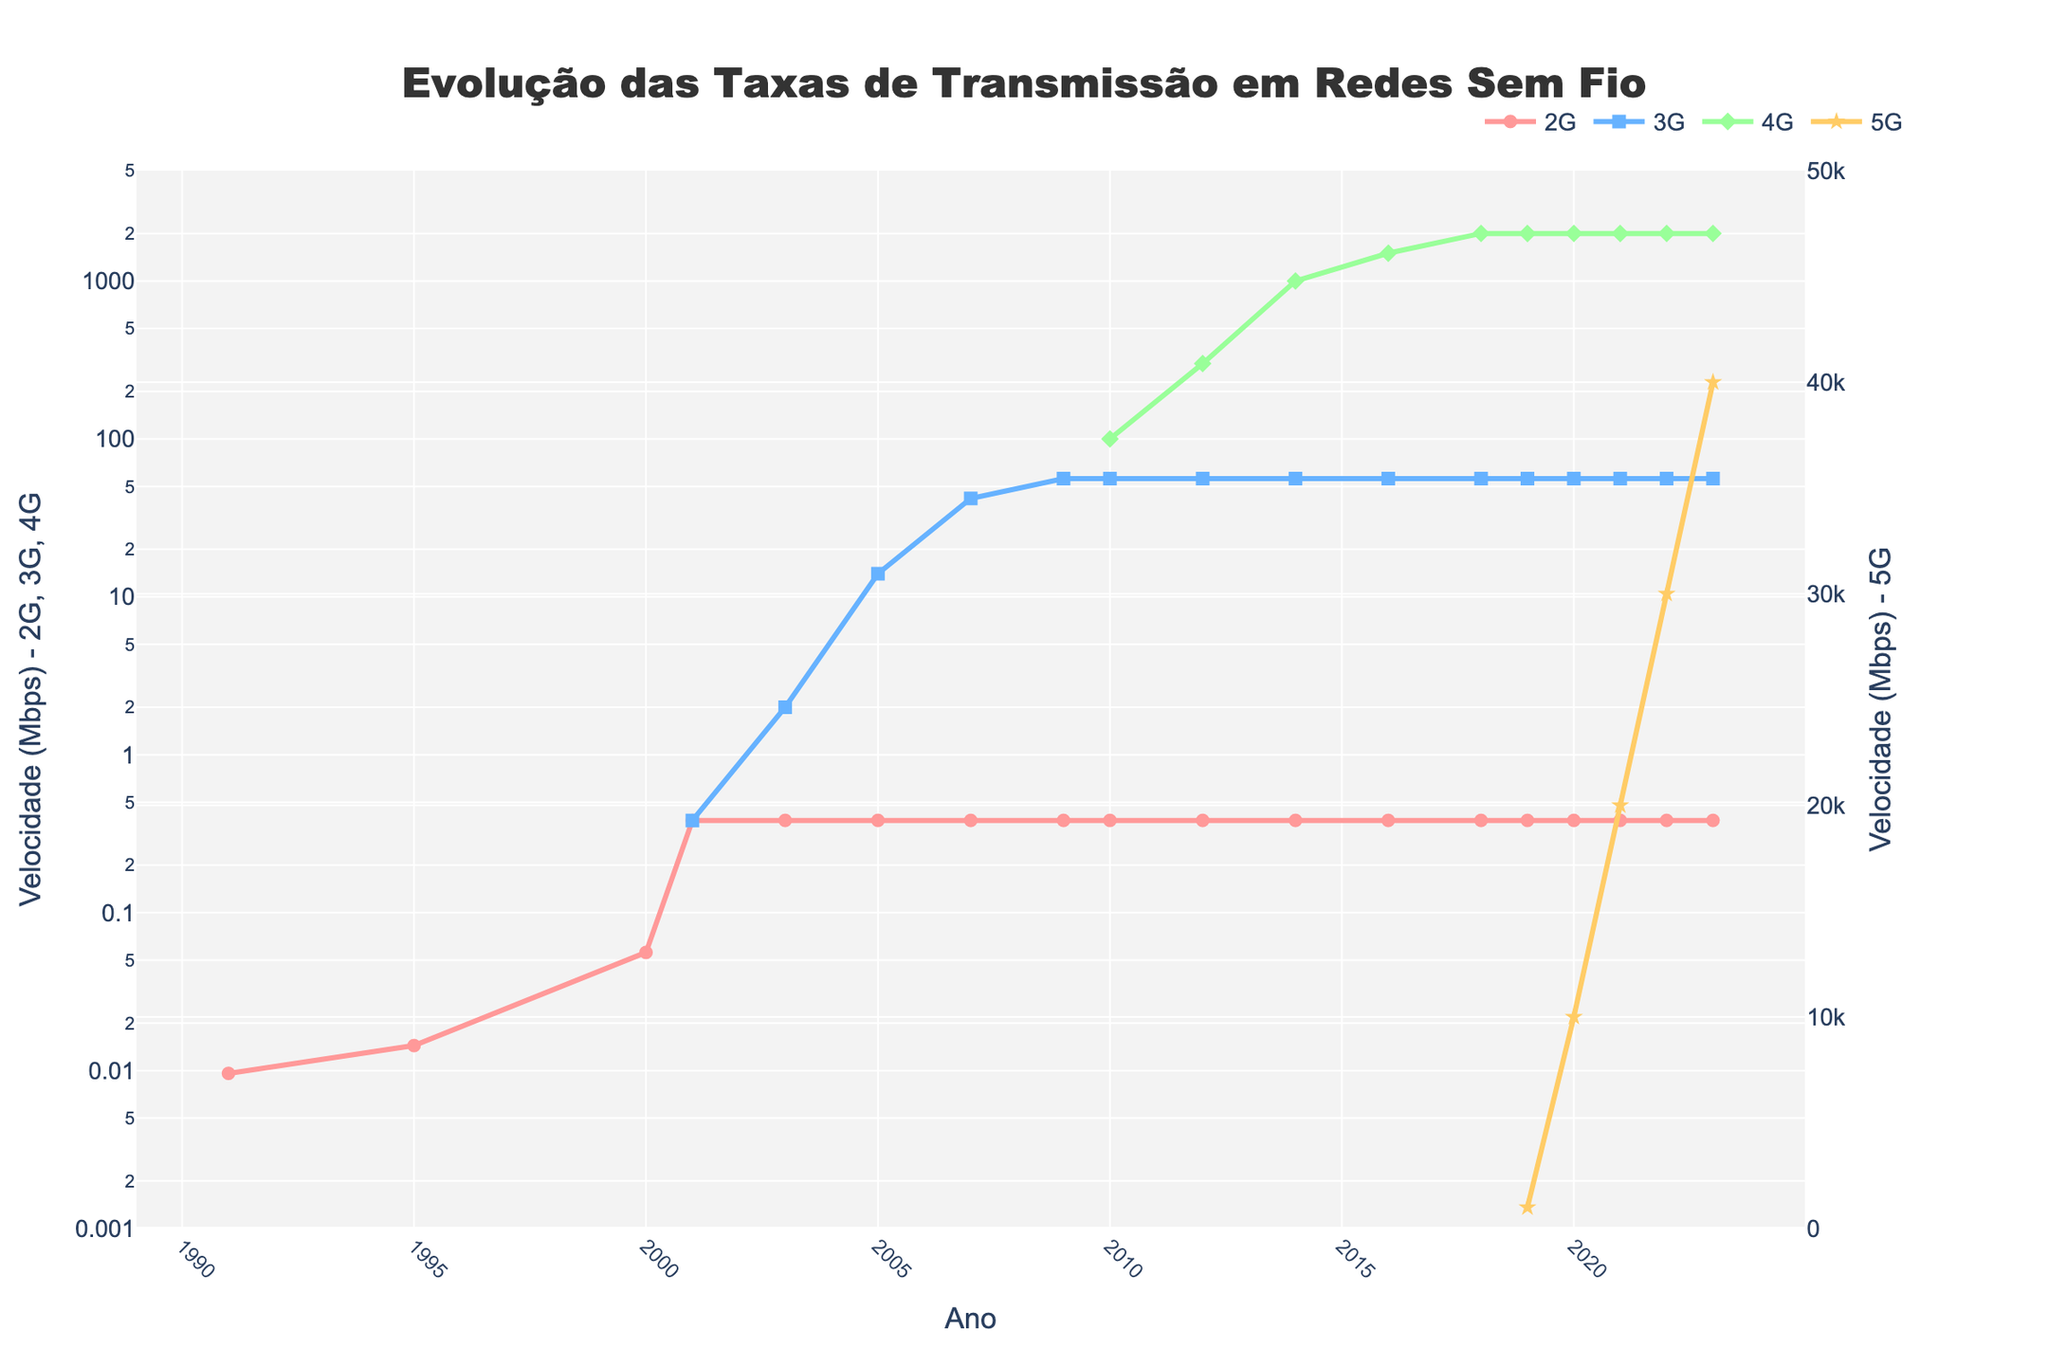What's the magnitude of increase in data rates from 2G to 3G in 2001? In 2001, 2G had a rate of 384 Kbps (or 0.384 Mbps after conversion). 3G also had a rate of 0.384 Mbps. The magnitude of increase is 0.384 Mbps - 0.384 Mbps = 0.
Answer: 0 Mbps Between which years did the 4G transition from Mbps to Gbps begin and end? The 4G rate first reached 1 Gbps in 2014 and was at Mbps in 2012. Therefore, the transition period was between 2012 to 2014.
Answer: 2012-2014 What is the difference in data rates between 3G and 4G in 2010? In 2010, the data rate for 3G is 56 Mbps, and for 4G is 100 Mbps. The difference is 100 Mbps - 56 Mbps = 44 Mbps.
Answer: 44 Mbps How has 5G’s data rate grown from 2019 to 2023? In 2019, 5G's rate was 1 Gbps (1000 Mbps) and in 2023, it reached 40 Gbps (40000 Mbps). Growth = 40000 Mbps - 1000 Mbps = 39000 Mbps.
Answer: 39000 Mbps What color and shape represent 5G on the plot? The figure legend indicates that 5G is represented by yellow lines and star-shaped markers.
Answer: Yellow, star Comparing 2010 data rates, which technology had the highest rate and what was it? In 2010, the data rates were 384 Kbps for 2G (0.384 Mbps), 56 Mbps for 3G, and 100 Mbps for 4G. 4G had the highest rate at 100 Mbps.
Answer: 4G, 100 Mbps What was the first year when the data rate of 4G surpassed 1 Gbps? The 4G rate reached 1000 Mbps (1 Gbps) for the first time in 2014.
Answer: 2014 By how much did 3G's rate increase from 2001 to 2005? In 2001, 3G's rate was 0.384 Mbps. By 2005, it increased to 14 Mbps. The increase is 14 Mbps - 0.384 Mbps = 13.616 Mbps.
Answer: 13.616 Mbps 